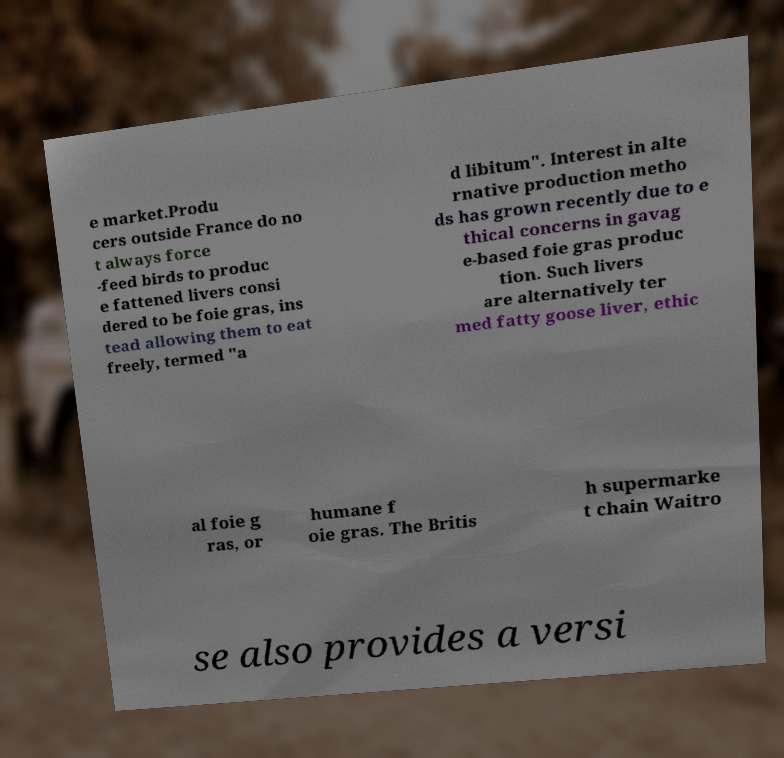There's text embedded in this image that I need extracted. Can you transcribe it verbatim? e market.Produ cers outside France do no t always force -feed birds to produc e fattened livers consi dered to be foie gras, ins tead allowing them to eat freely, termed "a d libitum". Interest in alte rnative production metho ds has grown recently due to e thical concerns in gavag e-based foie gras produc tion. Such livers are alternatively ter med fatty goose liver, ethic al foie g ras, or humane f oie gras. The Britis h supermarke t chain Waitro se also provides a versi 